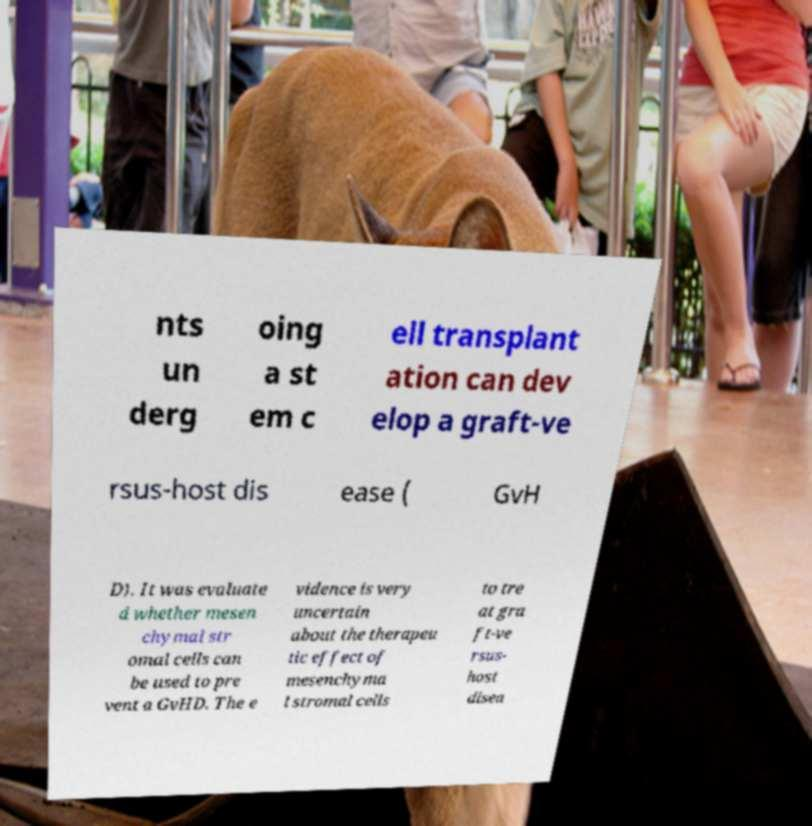I need the written content from this picture converted into text. Can you do that? nts un derg oing a st em c ell transplant ation can dev elop a graft-ve rsus-host dis ease ( GvH D). It was evaluate d whether mesen chymal str omal cells can be used to pre vent a GvHD. The e vidence is very uncertain about the therapeu tic effect of mesenchyma l stromal cells to tre at gra ft-ve rsus- host disea 